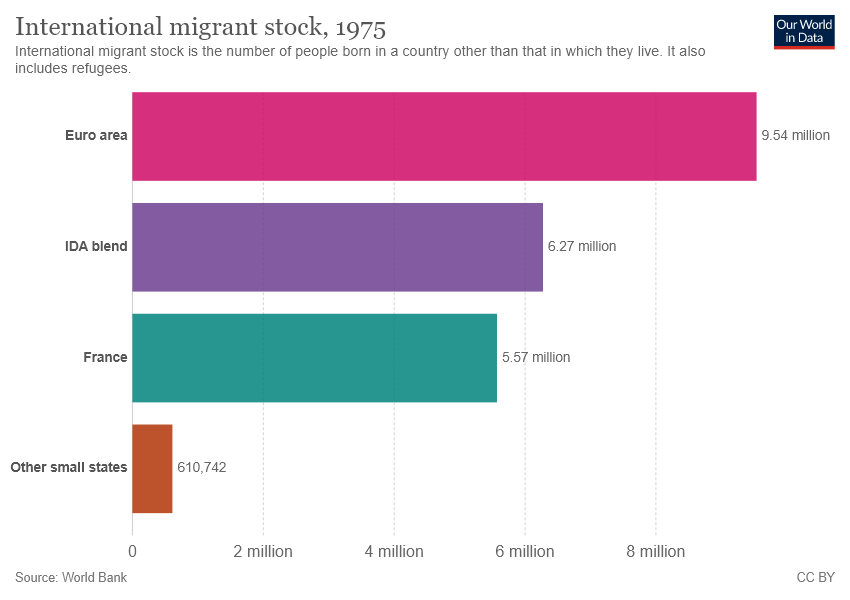Point out several critical features in this image. The number of international migrants in France is 5.57 million. 